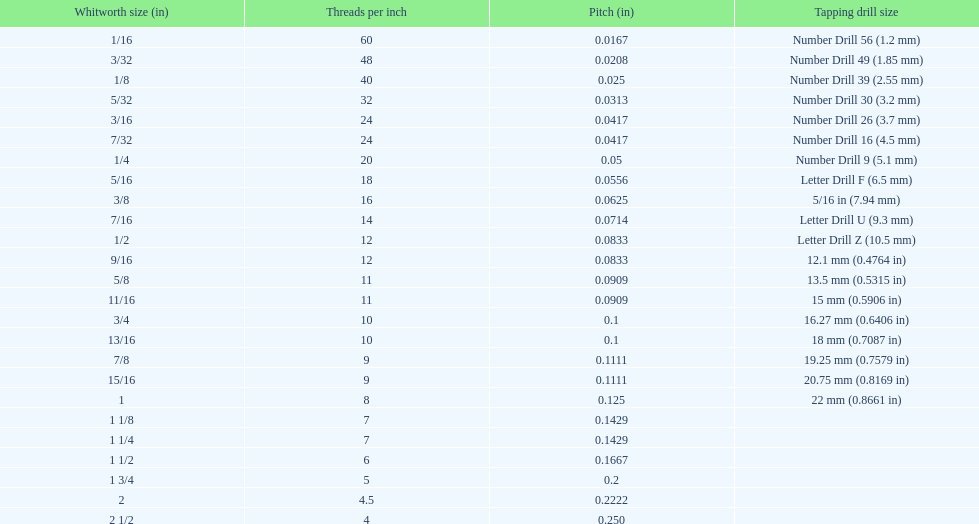What is the fundamental diameter of the beginning 1/8 whitworth measurement (in)? 0.0930. 